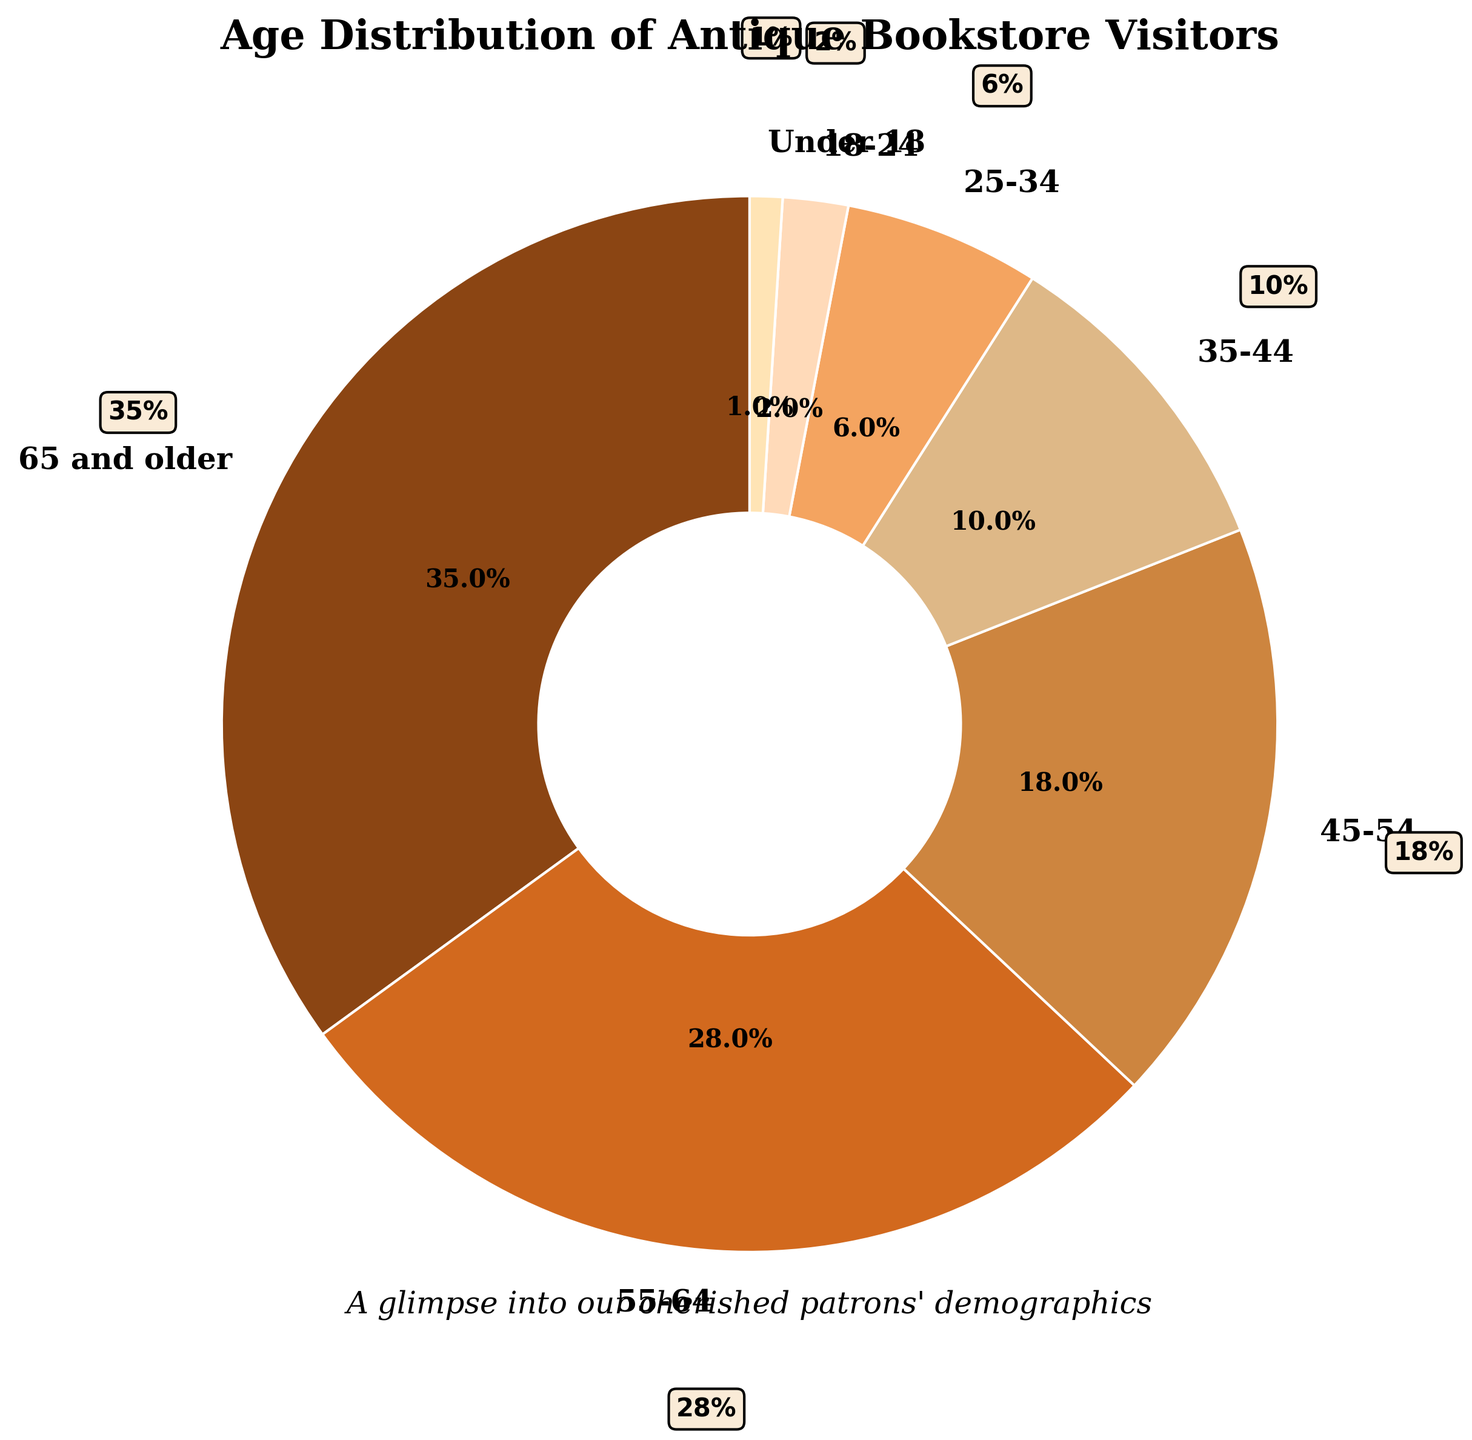What percentage of customers visiting the bookstore are 55 and older? Sum the percentages of the age groups "55-64" and "65 and older" by adding 28% and 35%, respectively. Thus, 28% + 35% = 63%.
Answer: 63% Which age group has the smallest percentage of visitors? Locate the smallest percentage among all the age groups by comparing each value. The smallest value is 1%, which corresponds to the "Under 18" age group.
Answer: Under 18 How many percentage points more visitors are 65 and older compared to 45-54? Subtract the percentage of the 45-54 age group from the 65 and older group by performing 35% - 18% = 17%.
Answer: 17% What is the total percentage of visitors under 35 years old? Add the percentages of the age groups "Under 18", "18-24", and "25-34" by performing 1% + 2% + 6%. Thus, 1% + 2% + 6% = 9%.
Answer: 9% Which age group is represented by the burnt sienna color? Visually identify the color burnt sienna (reddish-brown) in the pie chart. This color corresponds to the "55-64" age group.
Answer: 55-64 What’s the difference in percentage points between the largest and smallest age groups? Subtract the smallest percentage from the largest by calculating 35% (largest) - 1% (smallest) = 34%.
Answer: 34% What percentage of customers are between 35 and 54 years old? Add the percentages of the age groups "35-44" and "45-54" by performing 10% + 18%. Thus, 10% + 18% = 28%.
Answer: 28% Is the combined percentage of visitors aged 25-34 and 35-44 greater than the percentage of the 65 and older group? First, calculate the combined percentage of "25-34" and "35-44" by adding 6% + 10% = 16%. Next, compare this sum to 35%. Since 16% is less than 35%, the combined percentage is not greater.
Answer: No How much more popular is the 55-64 age group compared to the 18-24 age group? Subtract the percentage of the 18-24 age group from the 55-64 group by performing 28% - 2% = 26%.
Answer: 26% What is the second smallest age group percentage? Identify and compare all the percentages. The second smallest value after 1% (Under 18) is 2%, which corresponds to the "18-24" age group.
Answer: 18-24 